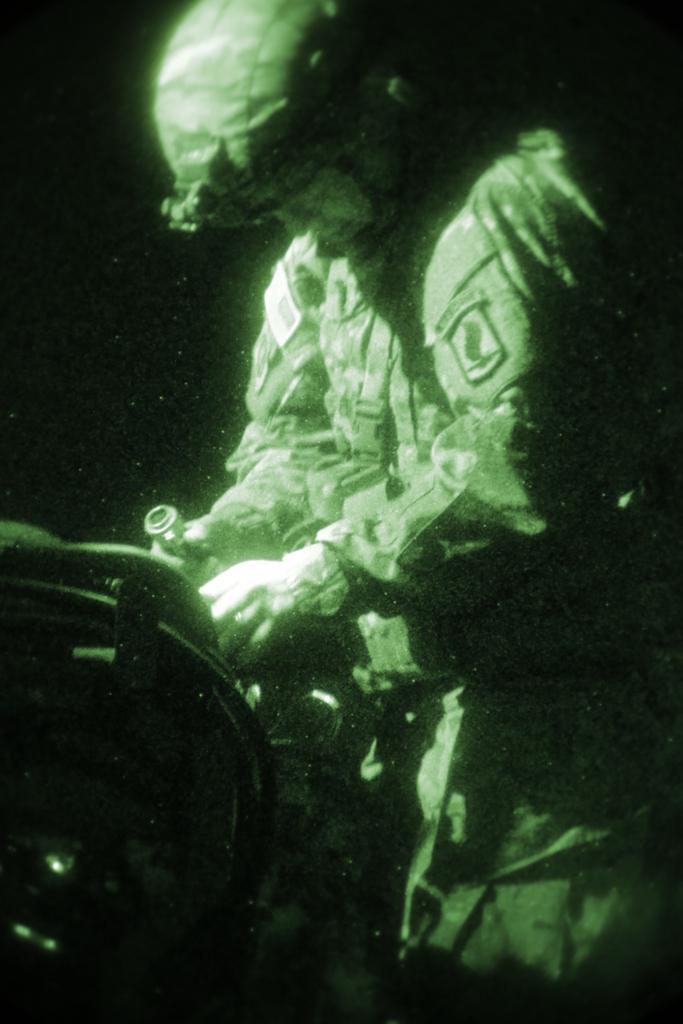Please provide a concise description of this image. In this image we can see a person and the person is holding an object. On the left side, we can see an object. The background of the image is dark. 